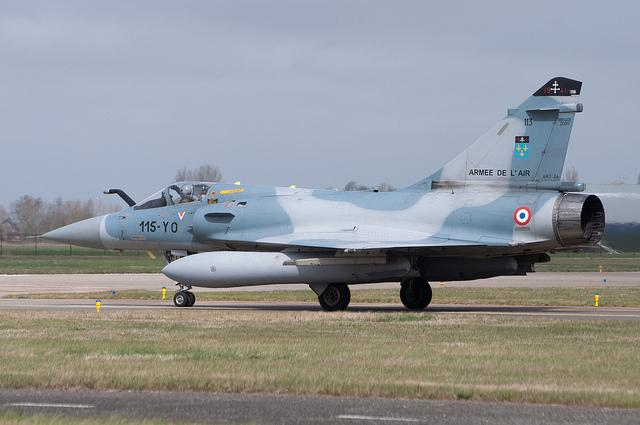What country does this plane belong to? Please explain your reasoning. france. The plane is a dassault mirage 2000c. there is an armed de l'air marking on the tail. 